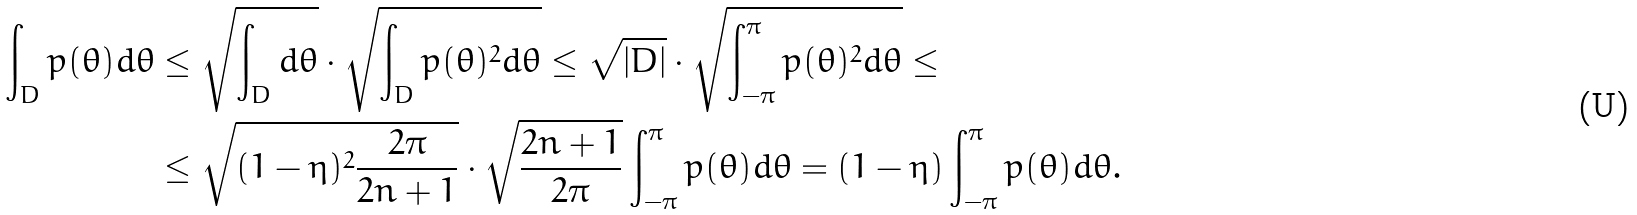Convert formula to latex. <formula><loc_0><loc_0><loc_500><loc_500>\int _ { D } p ( \theta ) d \theta & \leq \sqrt { \int _ { D } d \theta } \cdot \sqrt { \int _ { D } p ( \theta ) ^ { 2 } d \theta } \leq \sqrt { | D | } \cdot \sqrt { \int _ { - \pi } ^ { \pi } p ( \theta ) ^ { 2 } d \theta } \leq \\ & \leq \sqrt { ( 1 - \eta ) ^ { 2 } \frac { 2 \pi } { 2 n + 1 } } \cdot \sqrt { \frac { 2 n + 1 } { 2 \pi } } \int _ { - \pi } ^ { \pi } p ( \theta ) d \theta = ( 1 - \eta ) \int _ { - \pi } ^ { \pi } p ( \theta ) d \theta .</formula> 